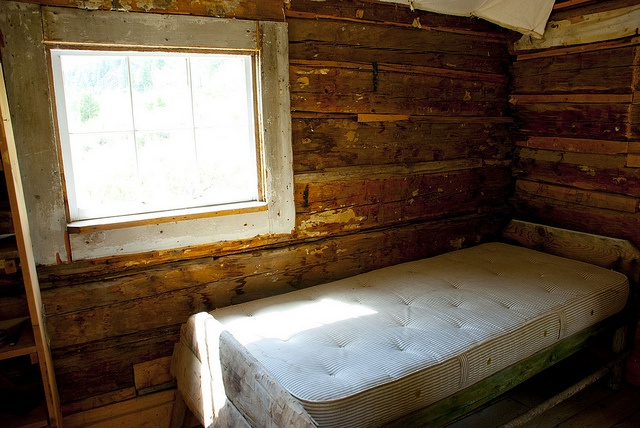Describe the objects in this image and their specific colors. I can see a bed in black, white, gray, and darkgray tones in this image. 